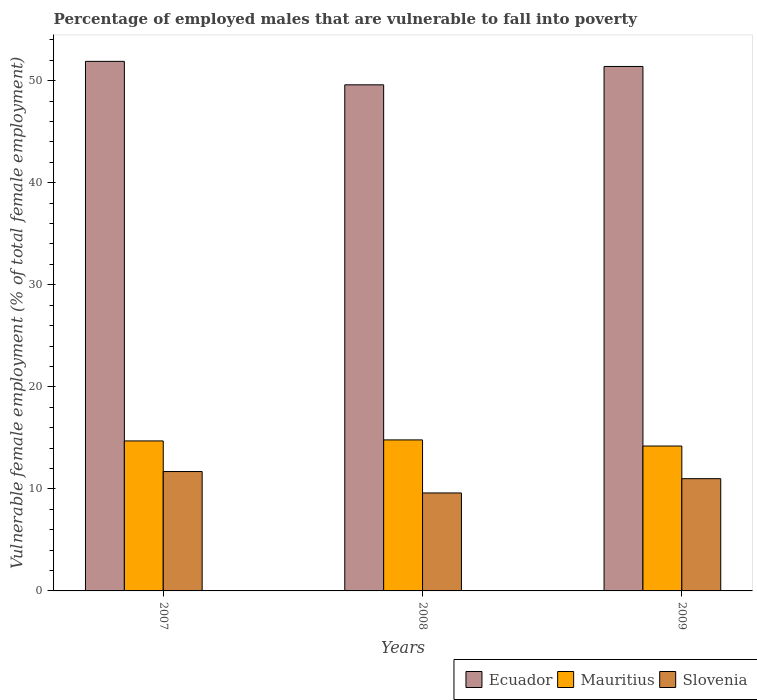How many different coloured bars are there?
Provide a short and direct response. 3. Are the number of bars per tick equal to the number of legend labels?
Ensure brevity in your answer.  Yes. How many bars are there on the 3rd tick from the right?
Offer a terse response. 3. What is the label of the 1st group of bars from the left?
Keep it short and to the point. 2007. In how many cases, is the number of bars for a given year not equal to the number of legend labels?
Ensure brevity in your answer.  0. Across all years, what is the maximum percentage of employed males who are vulnerable to fall into poverty in Slovenia?
Make the answer very short. 11.7. Across all years, what is the minimum percentage of employed males who are vulnerable to fall into poverty in Mauritius?
Keep it short and to the point. 14.2. In which year was the percentage of employed males who are vulnerable to fall into poverty in Slovenia minimum?
Your answer should be compact. 2008. What is the total percentage of employed males who are vulnerable to fall into poverty in Mauritius in the graph?
Offer a very short reply. 43.7. What is the difference between the percentage of employed males who are vulnerable to fall into poverty in Mauritius in 2007 and that in 2009?
Provide a succinct answer. 0.5. What is the difference between the percentage of employed males who are vulnerable to fall into poverty in Slovenia in 2007 and the percentage of employed males who are vulnerable to fall into poverty in Mauritius in 2008?
Ensure brevity in your answer.  -3.1. What is the average percentage of employed males who are vulnerable to fall into poverty in Slovenia per year?
Offer a very short reply. 10.77. In the year 2008, what is the difference between the percentage of employed males who are vulnerable to fall into poverty in Mauritius and percentage of employed males who are vulnerable to fall into poverty in Slovenia?
Ensure brevity in your answer.  5.2. In how many years, is the percentage of employed males who are vulnerable to fall into poverty in Mauritius greater than 30 %?
Your answer should be compact. 0. What is the ratio of the percentage of employed males who are vulnerable to fall into poverty in Mauritius in 2007 to that in 2009?
Keep it short and to the point. 1.04. Is the percentage of employed males who are vulnerable to fall into poverty in Slovenia in 2007 less than that in 2009?
Offer a very short reply. No. Is the difference between the percentage of employed males who are vulnerable to fall into poverty in Mauritius in 2008 and 2009 greater than the difference between the percentage of employed males who are vulnerable to fall into poverty in Slovenia in 2008 and 2009?
Provide a short and direct response. Yes. What is the difference between the highest and the second highest percentage of employed males who are vulnerable to fall into poverty in Slovenia?
Keep it short and to the point. 0.7. What is the difference between the highest and the lowest percentage of employed males who are vulnerable to fall into poverty in Slovenia?
Provide a succinct answer. 2.1. Is the sum of the percentage of employed males who are vulnerable to fall into poverty in Mauritius in 2007 and 2008 greater than the maximum percentage of employed males who are vulnerable to fall into poverty in Slovenia across all years?
Provide a short and direct response. Yes. What does the 1st bar from the left in 2007 represents?
Your answer should be compact. Ecuador. What does the 3rd bar from the right in 2008 represents?
Ensure brevity in your answer.  Ecuador. Are the values on the major ticks of Y-axis written in scientific E-notation?
Ensure brevity in your answer.  No. Does the graph contain any zero values?
Provide a succinct answer. No. Where does the legend appear in the graph?
Offer a very short reply. Bottom right. How many legend labels are there?
Make the answer very short. 3. What is the title of the graph?
Your response must be concise. Percentage of employed males that are vulnerable to fall into poverty. Does "Mozambique" appear as one of the legend labels in the graph?
Provide a short and direct response. No. What is the label or title of the Y-axis?
Offer a very short reply. Vulnerable female employment (% of total female employment). What is the Vulnerable female employment (% of total female employment) in Ecuador in 2007?
Ensure brevity in your answer.  51.9. What is the Vulnerable female employment (% of total female employment) of Mauritius in 2007?
Keep it short and to the point. 14.7. What is the Vulnerable female employment (% of total female employment) in Slovenia in 2007?
Offer a terse response. 11.7. What is the Vulnerable female employment (% of total female employment) in Ecuador in 2008?
Ensure brevity in your answer.  49.6. What is the Vulnerable female employment (% of total female employment) in Mauritius in 2008?
Your response must be concise. 14.8. What is the Vulnerable female employment (% of total female employment) in Slovenia in 2008?
Provide a succinct answer. 9.6. What is the Vulnerable female employment (% of total female employment) of Ecuador in 2009?
Offer a terse response. 51.4. What is the Vulnerable female employment (% of total female employment) of Mauritius in 2009?
Make the answer very short. 14.2. Across all years, what is the maximum Vulnerable female employment (% of total female employment) in Ecuador?
Provide a short and direct response. 51.9. Across all years, what is the maximum Vulnerable female employment (% of total female employment) of Mauritius?
Make the answer very short. 14.8. Across all years, what is the maximum Vulnerable female employment (% of total female employment) in Slovenia?
Make the answer very short. 11.7. Across all years, what is the minimum Vulnerable female employment (% of total female employment) in Ecuador?
Ensure brevity in your answer.  49.6. Across all years, what is the minimum Vulnerable female employment (% of total female employment) of Mauritius?
Provide a short and direct response. 14.2. Across all years, what is the minimum Vulnerable female employment (% of total female employment) in Slovenia?
Your response must be concise. 9.6. What is the total Vulnerable female employment (% of total female employment) in Ecuador in the graph?
Ensure brevity in your answer.  152.9. What is the total Vulnerable female employment (% of total female employment) of Mauritius in the graph?
Provide a succinct answer. 43.7. What is the total Vulnerable female employment (% of total female employment) in Slovenia in the graph?
Your answer should be compact. 32.3. What is the difference between the Vulnerable female employment (% of total female employment) in Mauritius in 2007 and that in 2009?
Make the answer very short. 0.5. What is the difference between the Vulnerable female employment (% of total female employment) of Ecuador in 2007 and the Vulnerable female employment (% of total female employment) of Mauritius in 2008?
Offer a terse response. 37.1. What is the difference between the Vulnerable female employment (% of total female employment) of Ecuador in 2007 and the Vulnerable female employment (% of total female employment) of Slovenia in 2008?
Ensure brevity in your answer.  42.3. What is the difference between the Vulnerable female employment (% of total female employment) in Ecuador in 2007 and the Vulnerable female employment (% of total female employment) in Mauritius in 2009?
Ensure brevity in your answer.  37.7. What is the difference between the Vulnerable female employment (% of total female employment) of Ecuador in 2007 and the Vulnerable female employment (% of total female employment) of Slovenia in 2009?
Ensure brevity in your answer.  40.9. What is the difference between the Vulnerable female employment (% of total female employment) in Ecuador in 2008 and the Vulnerable female employment (% of total female employment) in Mauritius in 2009?
Your response must be concise. 35.4. What is the difference between the Vulnerable female employment (% of total female employment) of Ecuador in 2008 and the Vulnerable female employment (% of total female employment) of Slovenia in 2009?
Offer a very short reply. 38.6. What is the average Vulnerable female employment (% of total female employment) in Ecuador per year?
Ensure brevity in your answer.  50.97. What is the average Vulnerable female employment (% of total female employment) in Mauritius per year?
Make the answer very short. 14.57. What is the average Vulnerable female employment (% of total female employment) of Slovenia per year?
Your answer should be compact. 10.77. In the year 2007, what is the difference between the Vulnerable female employment (% of total female employment) of Ecuador and Vulnerable female employment (% of total female employment) of Mauritius?
Give a very brief answer. 37.2. In the year 2007, what is the difference between the Vulnerable female employment (% of total female employment) of Ecuador and Vulnerable female employment (% of total female employment) of Slovenia?
Give a very brief answer. 40.2. In the year 2008, what is the difference between the Vulnerable female employment (% of total female employment) in Ecuador and Vulnerable female employment (% of total female employment) in Mauritius?
Give a very brief answer. 34.8. In the year 2009, what is the difference between the Vulnerable female employment (% of total female employment) of Ecuador and Vulnerable female employment (% of total female employment) of Mauritius?
Your answer should be compact. 37.2. In the year 2009, what is the difference between the Vulnerable female employment (% of total female employment) of Ecuador and Vulnerable female employment (% of total female employment) of Slovenia?
Give a very brief answer. 40.4. In the year 2009, what is the difference between the Vulnerable female employment (% of total female employment) in Mauritius and Vulnerable female employment (% of total female employment) in Slovenia?
Keep it short and to the point. 3.2. What is the ratio of the Vulnerable female employment (% of total female employment) of Ecuador in 2007 to that in 2008?
Provide a short and direct response. 1.05. What is the ratio of the Vulnerable female employment (% of total female employment) of Slovenia in 2007 to that in 2008?
Give a very brief answer. 1.22. What is the ratio of the Vulnerable female employment (% of total female employment) in Ecuador in 2007 to that in 2009?
Provide a succinct answer. 1.01. What is the ratio of the Vulnerable female employment (% of total female employment) of Mauritius in 2007 to that in 2009?
Give a very brief answer. 1.04. What is the ratio of the Vulnerable female employment (% of total female employment) in Slovenia in 2007 to that in 2009?
Make the answer very short. 1.06. What is the ratio of the Vulnerable female employment (% of total female employment) in Mauritius in 2008 to that in 2009?
Keep it short and to the point. 1.04. What is the ratio of the Vulnerable female employment (% of total female employment) of Slovenia in 2008 to that in 2009?
Ensure brevity in your answer.  0.87. What is the difference between the highest and the second highest Vulnerable female employment (% of total female employment) in Ecuador?
Ensure brevity in your answer.  0.5. What is the difference between the highest and the second highest Vulnerable female employment (% of total female employment) of Slovenia?
Give a very brief answer. 0.7. What is the difference between the highest and the lowest Vulnerable female employment (% of total female employment) of Mauritius?
Your response must be concise. 0.6. What is the difference between the highest and the lowest Vulnerable female employment (% of total female employment) in Slovenia?
Provide a short and direct response. 2.1. 